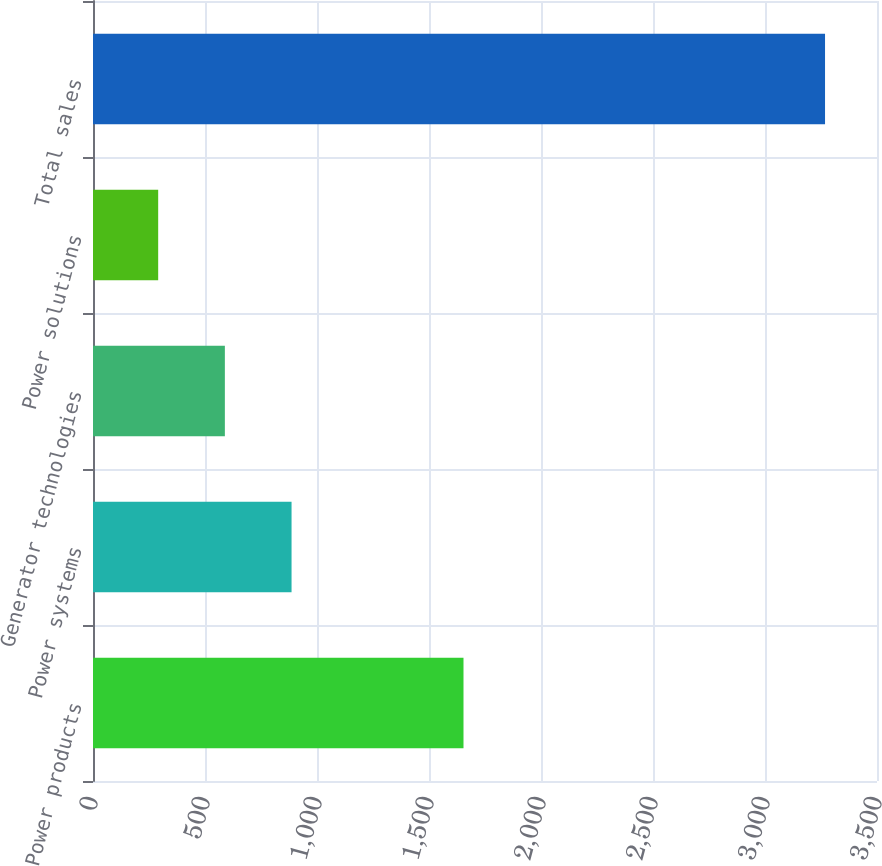Convert chart to OTSL. <chart><loc_0><loc_0><loc_500><loc_500><bar_chart><fcel>Power products<fcel>Power systems<fcel>Generator technologies<fcel>Power solutions<fcel>Total sales<nl><fcel>1654<fcel>886.4<fcel>588.7<fcel>291<fcel>3268<nl></chart> 